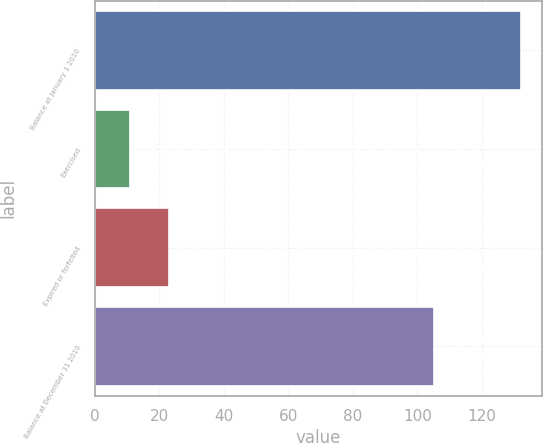Convert chart. <chart><loc_0><loc_0><loc_500><loc_500><bar_chart><fcel>Balance at January 1 2010<fcel>Exercised<fcel>Expired or forfeited<fcel>Balance at December 31 2010<nl><fcel>132<fcel>11<fcel>23.1<fcel>105<nl></chart> 